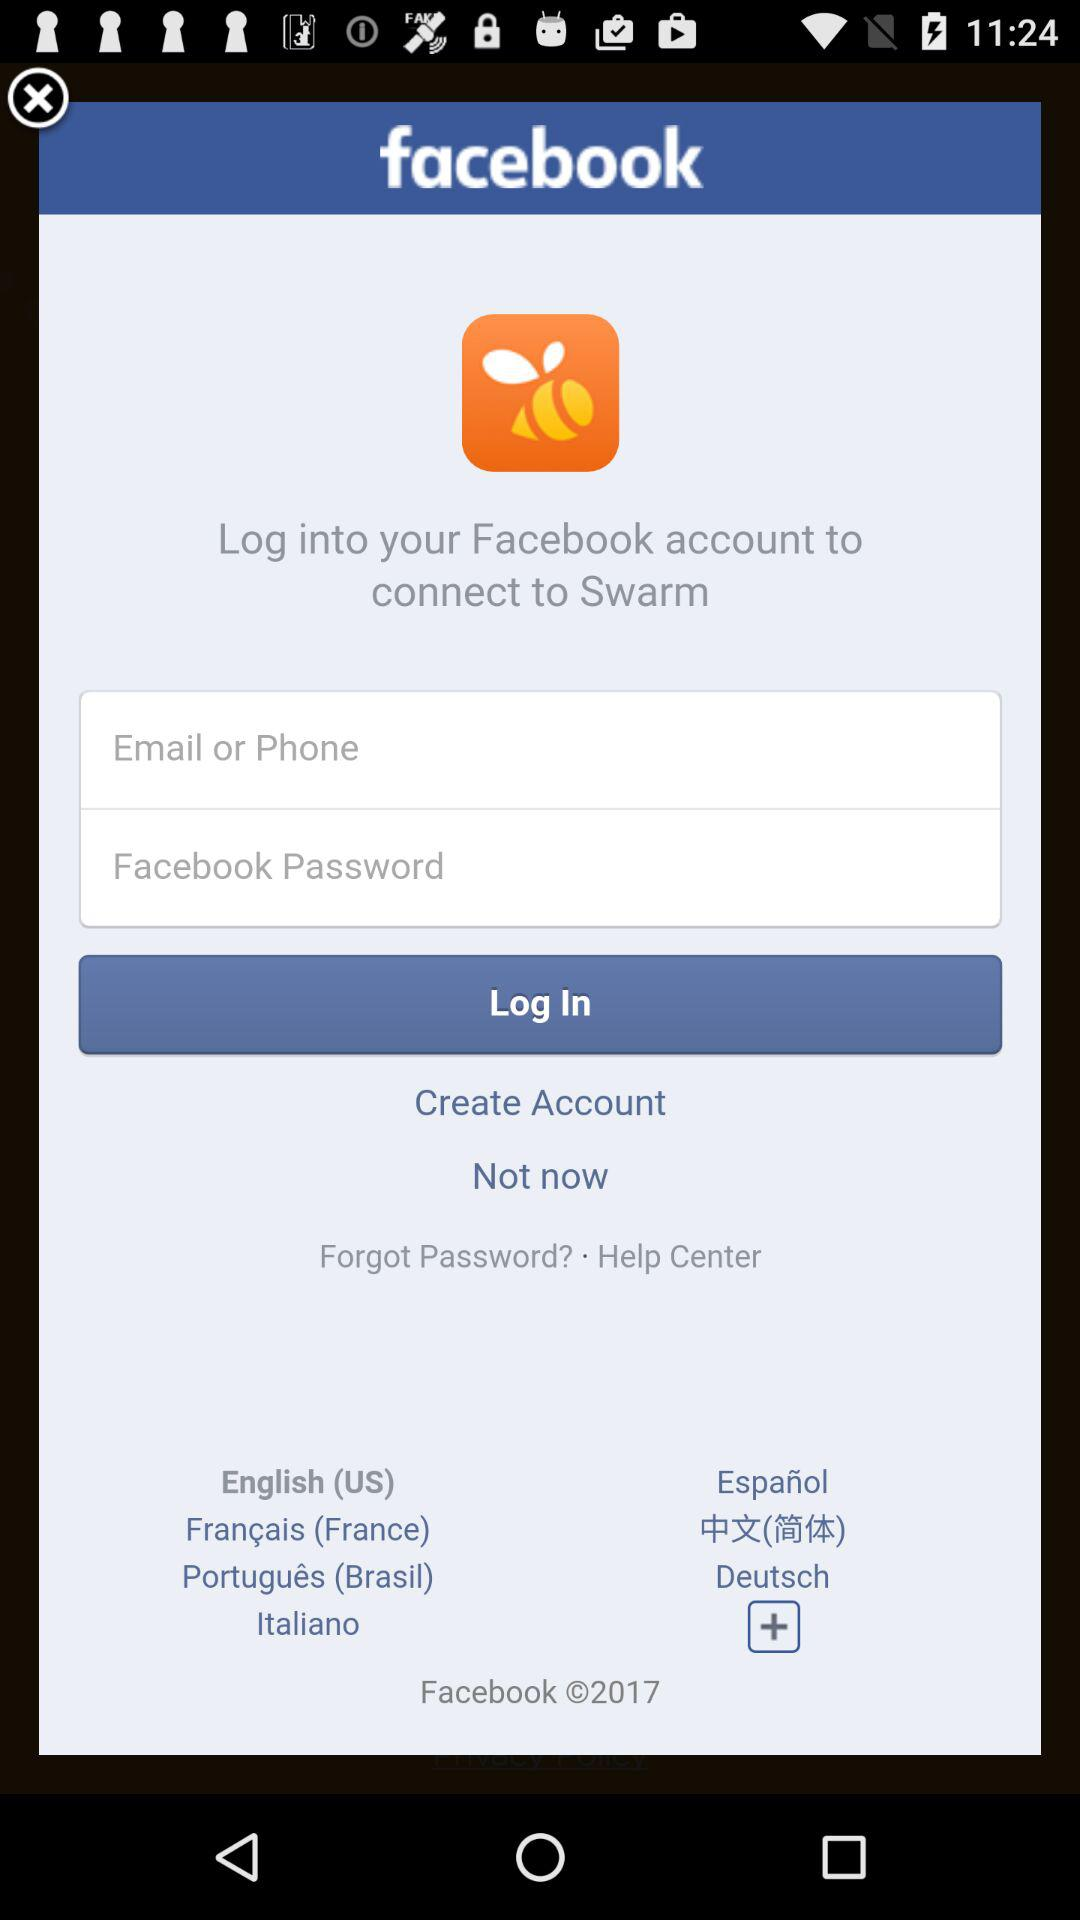After logging in with the "Facebook" account, what application will be connected? The application is "Swarm". 